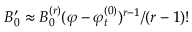<formula> <loc_0><loc_0><loc_500><loc_500>B _ { 0 } ^ { \prime } \approx B _ { 0 } ^ { ( r ) } ( \varphi - \varphi _ { t } ^ { ( 0 ) } ) ^ { r - 1 } / ( r - 1 ) !</formula> 